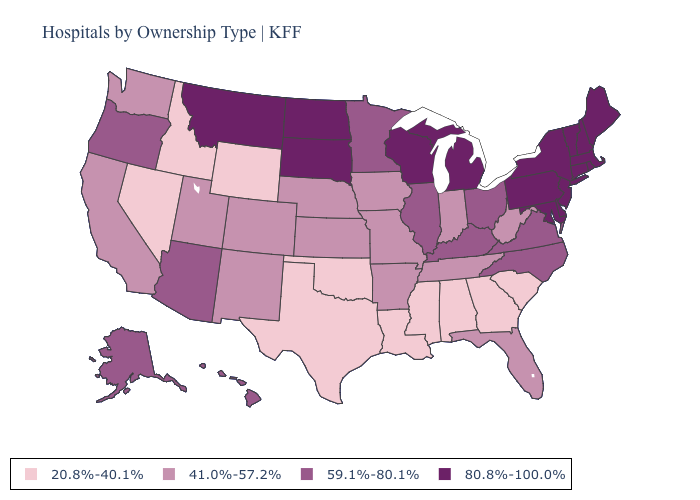Does Delaware have the highest value in the South?
Answer briefly. Yes. Does Wyoming have the lowest value in the USA?
Keep it brief. Yes. Does the map have missing data?
Short answer required. No. Among the states that border Kentucky , which have the highest value?
Be succinct. Illinois, Ohio, Virginia. Does West Virginia have a lower value than New Jersey?
Quick response, please. Yes. What is the value of Connecticut?
Answer briefly. 80.8%-100.0%. Among the states that border New Jersey , which have the highest value?
Be succinct. Delaware, New York, Pennsylvania. Does the first symbol in the legend represent the smallest category?
Write a very short answer. Yes. Does Maryland have the lowest value in the South?
Concise answer only. No. What is the value of Missouri?
Keep it brief. 41.0%-57.2%. Does the first symbol in the legend represent the smallest category?
Write a very short answer. Yes. Which states have the lowest value in the Northeast?
Quick response, please. Connecticut, Maine, Massachusetts, New Hampshire, New Jersey, New York, Pennsylvania, Rhode Island, Vermont. What is the lowest value in the USA?
Answer briefly. 20.8%-40.1%. Does Mississippi have the lowest value in the South?
Write a very short answer. Yes. What is the lowest value in the MidWest?
Be succinct. 41.0%-57.2%. 